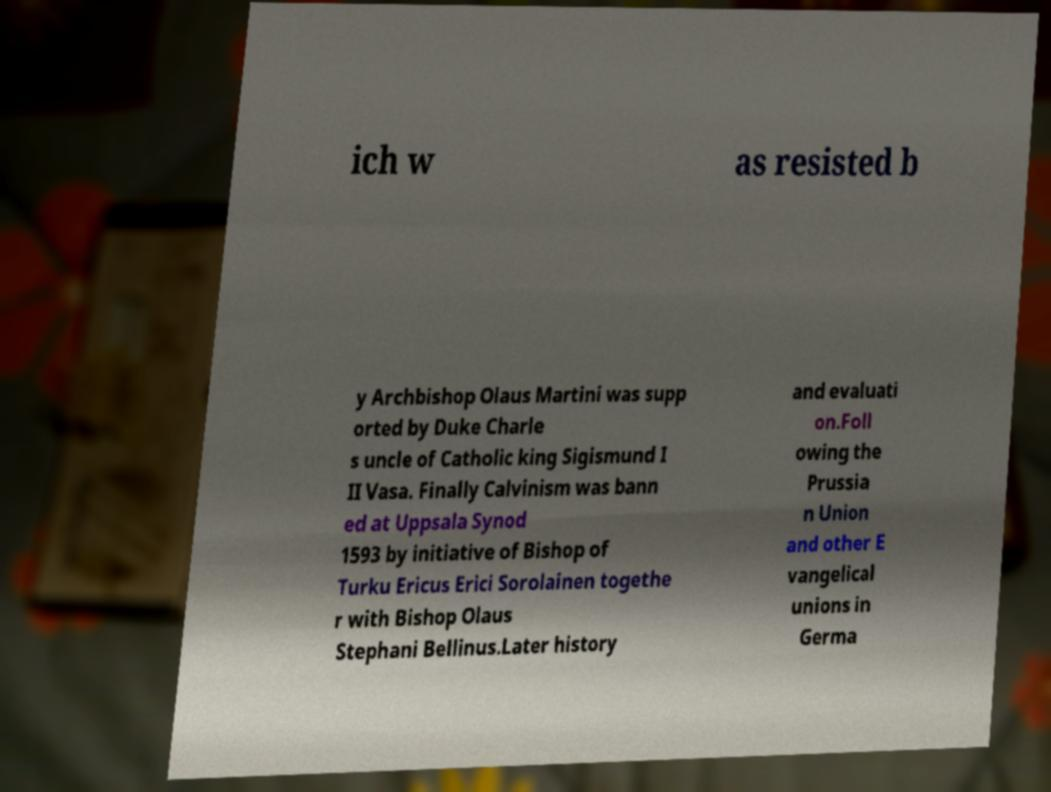There's text embedded in this image that I need extracted. Can you transcribe it verbatim? ich w as resisted b y Archbishop Olaus Martini was supp orted by Duke Charle s uncle of Catholic king Sigismund I II Vasa. Finally Calvinism was bann ed at Uppsala Synod 1593 by initiative of Bishop of Turku Ericus Erici Sorolainen togethe r with Bishop Olaus Stephani Bellinus.Later history and evaluati on.Foll owing the Prussia n Union and other E vangelical unions in Germa 